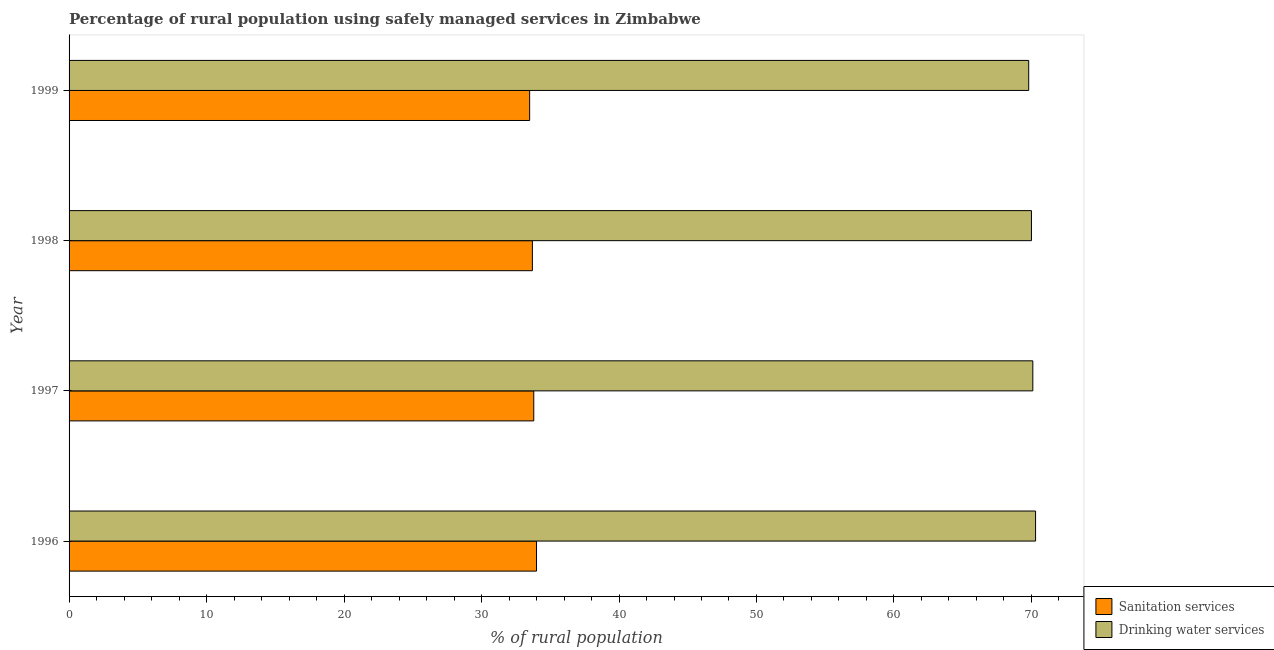How many groups of bars are there?
Your response must be concise. 4. How many bars are there on the 1st tick from the top?
Offer a very short reply. 2. What is the percentage of rural population who used sanitation services in 1996?
Make the answer very short. 34. Across all years, what is the maximum percentage of rural population who used drinking water services?
Offer a terse response. 70.3. Across all years, what is the minimum percentage of rural population who used drinking water services?
Keep it short and to the point. 69.8. In which year was the percentage of rural population who used sanitation services minimum?
Provide a succinct answer. 1999. What is the total percentage of rural population who used sanitation services in the graph?
Provide a short and direct response. 135. What is the difference between the percentage of rural population who used sanitation services in 1999 and the percentage of rural population who used drinking water services in 1996?
Make the answer very short. -36.8. What is the average percentage of rural population who used sanitation services per year?
Keep it short and to the point. 33.75. In the year 1999, what is the difference between the percentage of rural population who used sanitation services and percentage of rural population who used drinking water services?
Make the answer very short. -36.3. Is the percentage of rural population who used sanitation services in 1996 less than that in 1997?
Provide a short and direct response. No. What is the difference between the highest and the second highest percentage of rural population who used drinking water services?
Offer a very short reply. 0.2. What is the difference between the highest and the lowest percentage of rural population who used sanitation services?
Provide a succinct answer. 0.5. What does the 2nd bar from the top in 1996 represents?
Make the answer very short. Sanitation services. What does the 2nd bar from the bottom in 1998 represents?
Offer a very short reply. Drinking water services. Are all the bars in the graph horizontal?
Offer a terse response. Yes. What is the difference between two consecutive major ticks on the X-axis?
Offer a very short reply. 10. Does the graph contain any zero values?
Your answer should be very brief. No. How many legend labels are there?
Keep it short and to the point. 2. What is the title of the graph?
Make the answer very short. Percentage of rural population using safely managed services in Zimbabwe. Does "Arms exports" appear as one of the legend labels in the graph?
Give a very brief answer. No. What is the label or title of the X-axis?
Your response must be concise. % of rural population. What is the label or title of the Y-axis?
Your response must be concise. Year. What is the % of rural population of Drinking water services in 1996?
Offer a very short reply. 70.3. What is the % of rural population of Sanitation services in 1997?
Your answer should be compact. 33.8. What is the % of rural population of Drinking water services in 1997?
Provide a short and direct response. 70.1. What is the % of rural population of Sanitation services in 1998?
Provide a short and direct response. 33.7. What is the % of rural population of Sanitation services in 1999?
Offer a very short reply. 33.5. What is the % of rural population of Drinking water services in 1999?
Keep it short and to the point. 69.8. Across all years, what is the maximum % of rural population of Drinking water services?
Make the answer very short. 70.3. Across all years, what is the minimum % of rural population of Sanitation services?
Provide a short and direct response. 33.5. Across all years, what is the minimum % of rural population in Drinking water services?
Give a very brief answer. 69.8. What is the total % of rural population in Sanitation services in the graph?
Ensure brevity in your answer.  135. What is the total % of rural population of Drinking water services in the graph?
Give a very brief answer. 280.2. What is the difference between the % of rural population in Sanitation services in 1996 and that in 1997?
Provide a succinct answer. 0.2. What is the difference between the % of rural population of Sanitation services in 1996 and that in 1998?
Your answer should be compact. 0.3. What is the difference between the % of rural population in Drinking water services in 1996 and that in 1998?
Ensure brevity in your answer.  0.3. What is the difference between the % of rural population of Sanitation services in 1996 and that in 1999?
Offer a very short reply. 0.5. What is the difference between the % of rural population of Drinking water services in 1996 and that in 1999?
Give a very brief answer. 0.5. What is the difference between the % of rural population in Sanitation services in 1997 and that in 1998?
Your response must be concise. 0.1. What is the difference between the % of rural population in Drinking water services in 1997 and that in 1998?
Provide a succinct answer. 0.1. What is the difference between the % of rural population of Drinking water services in 1997 and that in 1999?
Provide a short and direct response. 0.3. What is the difference between the % of rural population of Drinking water services in 1998 and that in 1999?
Keep it short and to the point. 0.2. What is the difference between the % of rural population in Sanitation services in 1996 and the % of rural population in Drinking water services in 1997?
Provide a succinct answer. -36.1. What is the difference between the % of rural population of Sanitation services in 1996 and the % of rural population of Drinking water services in 1998?
Give a very brief answer. -36. What is the difference between the % of rural population of Sanitation services in 1996 and the % of rural population of Drinking water services in 1999?
Your answer should be very brief. -35.8. What is the difference between the % of rural population in Sanitation services in 1997 and the % of rural population in Drinking water services in 1998?
Your answer should be very brief. -36.2. What is the difference between the % of rural population of Sanitation services in 1997 and the % of rural population of Drinking water services in 1999?
Your answer should be compact. -36. What is the difference between the % of rural population in Sanitation services in 1998 and the % of rural population in Drinking water services in 1999?
Offer a very short reply. -36.1. What is the average % of rural population in Sanitation services per year?
Offer a terse response. 33.75. What is the average % of rural population of Drinking water services per year?
Keep it short and to the point. 70.05. In the year 1996, what is the difference between the % of rural population of Sanitation services and % of rural population of Drinking water services?
Your answer should be very brief. -36.3. In the year 1997, what is the difference between the % of rural population in Sanitation services and % of rural population in Drinking water services?
Your response must be concise. -36.3. In the year 1998, what is the difference between the % of rural population in Sanitation services and % of rural population in Drinking water services?
Provide a succinct answer. -36.3. In the year 1999, what is the difference between the % of rural population in Sanitation services and % of rural population in Drinking water services?
Ensure brevity in your answer.  -36.3. What is the ratio of the % of rural population in Sanitation services in 1996 to that in 1997?
Offer a terse response. 1.01. What is the ratio of the % of rural population in Drinking water services in 1996 to that in 1997?
Give a very brief answer. 1. What is the ratio of the % of rural population of Sanitation services in 1996 to that in 1998?
Offer a terse response. 1.01. What is the ratio of the % of rural population of Sanitation services in 1996 to that in 1999?
Ensure brevity in your answer.  1.01. What is the ratio of the % of rural population in Drinking water services in 1996 to that in 1999?
Provide a succinct answer. 1.01. What is the ratio of the % of rural population in Sanitation services in 1997 to that in 1998?
Make the answer very short. 1. What is the ratio of the % of rural population in Drinking water services in 1997 to that in 1998?
Your answer should be very brief. 1. What is the ratio of the % of rural population of Drinking water services in 1997 to that in 1999?
Provide a succinct answer. 1. What is the ratio of the % of rural population of Sanitation services in 1998 to that in 1999?
Provide a short and direct response. 1.01. What is the ratio of the % of rural population in Drinking water services in 1998 to that in 1999?
Your answer should be compact. 1. 